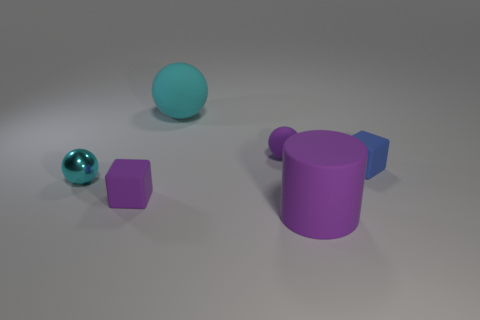Subtract all blue balls. Subtract all red cylinders. How many balls are left? 3 Add 1 blocks. How many objects exist? 7 Subtract all blocks. How many objects are left? 4 Subtract 2 cyan spheres. How many objects are left? 4 Subtract all large purple cylinders. Subtract all purple balls. How many objects are left? 4 Add 3 purple blocks. How many purple blocks are left? 4 Add 1 cyan rubber balls. How many cyan rubber balls exist? 2 